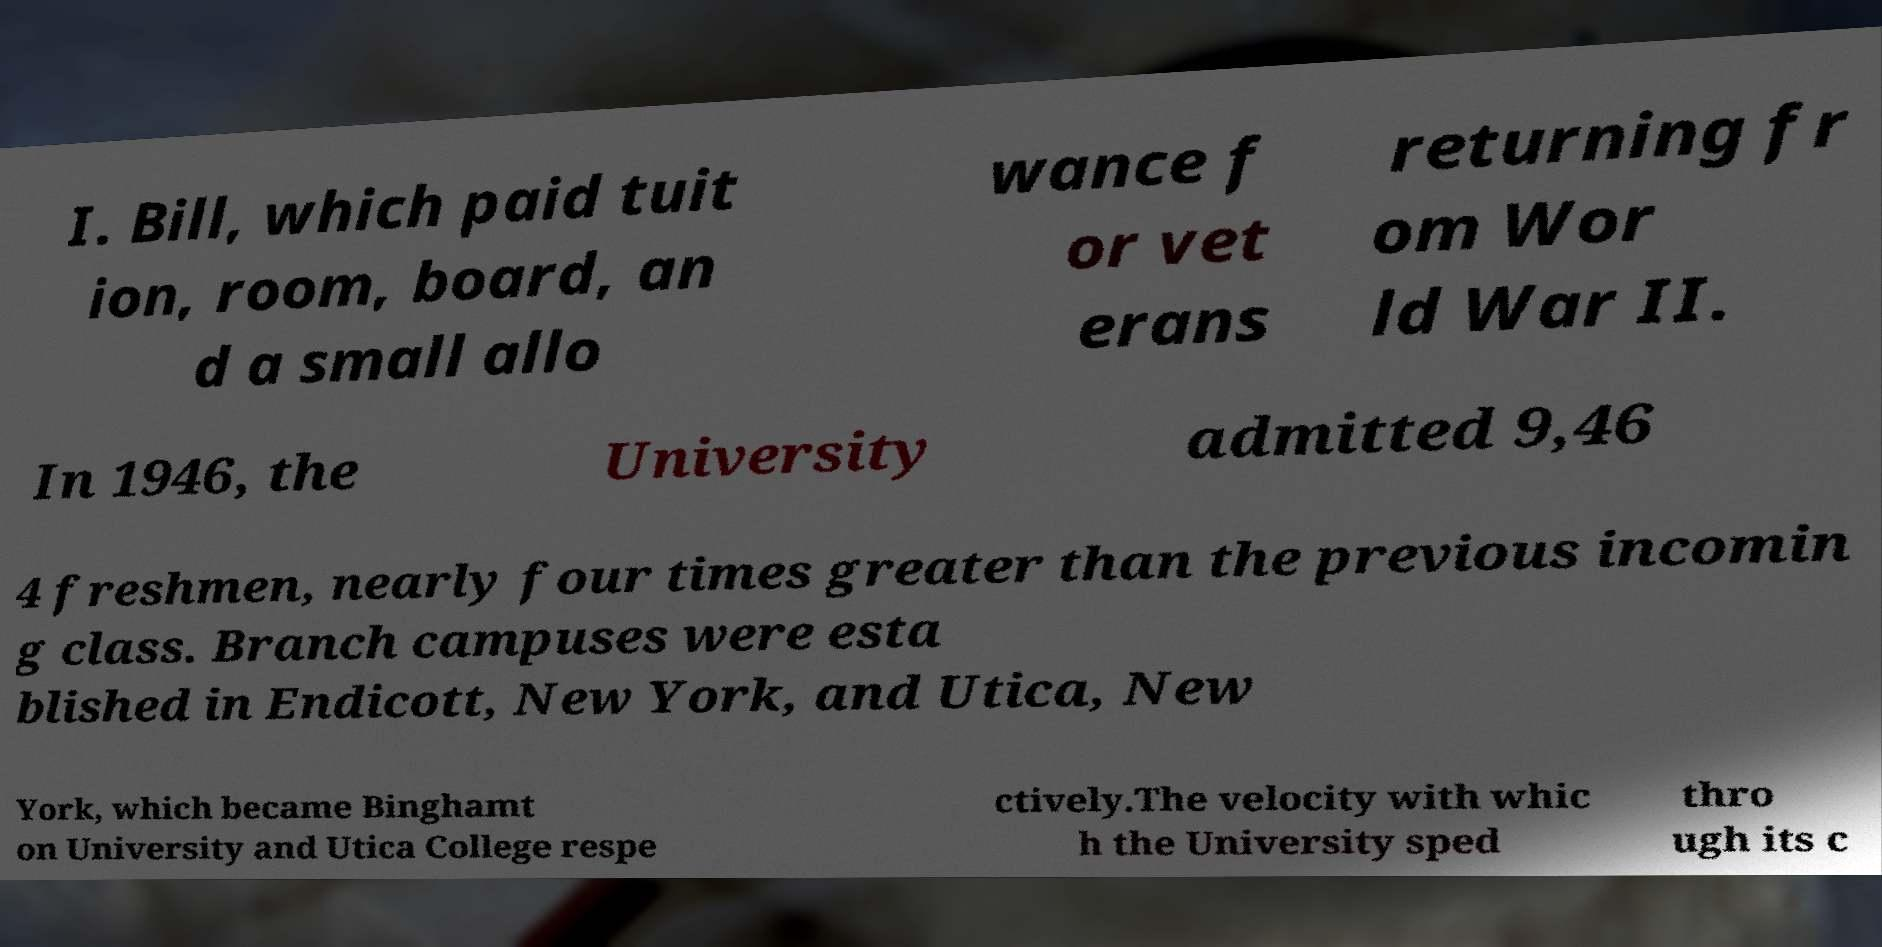Please read and relay the text visible in this image. What does it say? I. Bill, which paid tuit ion, room, board, an d a small allo wance f or vet erans returning fr om Wor ld War II. In 1946, the University admitted 9,46 4 freshmen, nearly four times greater than the previous incomin g class. Branch campuses were esta blished in Endicott, New York, and Utica, New York, which became Binghamt on University and Utica College respe ctively.The velocity with whic h the University sped thro ugh its c 